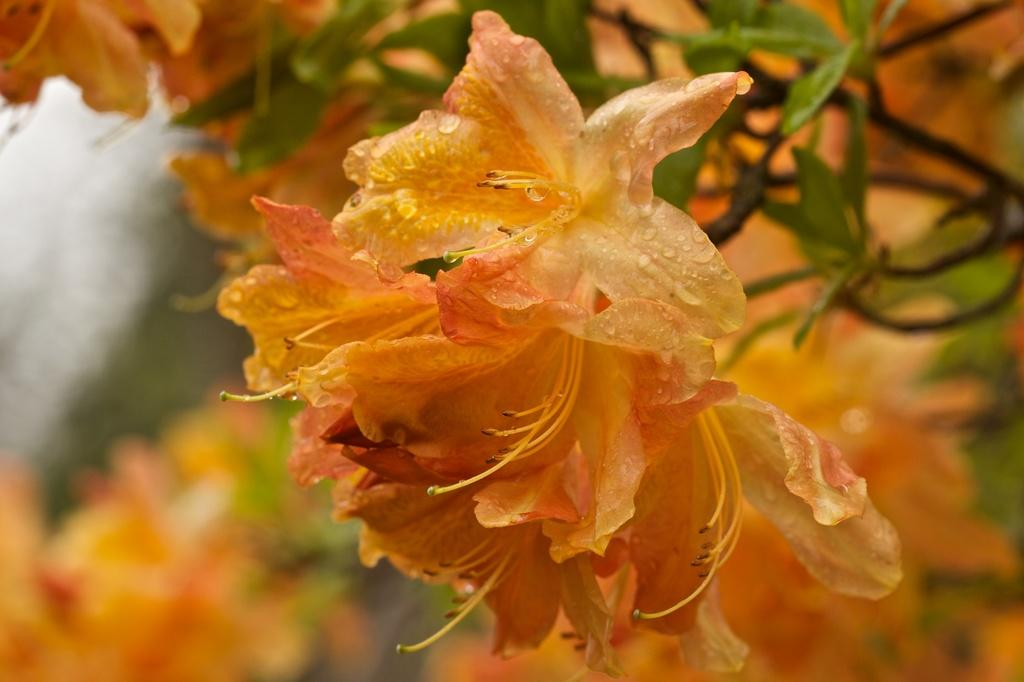What type of plants can be seen in the image? There are flowers in the image. Can you describe the background of the image? The background of the image is blurred. How many cherries can be seen in the image? There are no cherries present in the image; it features flowers and a blurred background. What type of grip is required to hold the flowers in the image? There is no need to grip the flowers in the image, as they are not physically present in a way that would require holding. 